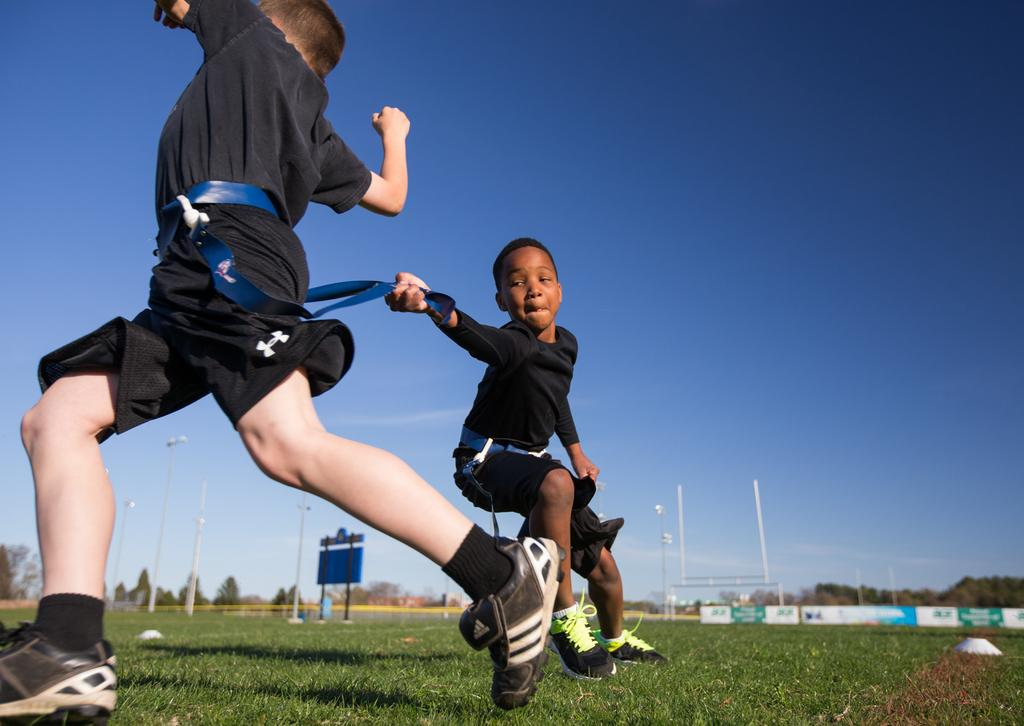What is the main subject of the image? There is a boy in the image. What is the boy holding in the image? The boy is holding a belt of another person. What structures can be seen in the image? There are poles, lights, and boards in the image. What type of natural elements are present in the image? There are trees in the image. What can be seen in the background of the image? The sky is visible in the background of the image. What is the governor's opinion on the trail in the image? There is no governor or trail present in the image, so it is not possible to determine their opinion. 